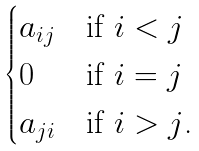<formula> <loc_0><loc_0><loc_500><loc_500>\begin{cases} a _ { i j } & \text {if $i<j$} \\ 0 & \text {if $i=j$} \\ a _ { j i } & \text {if $i>j$.} \end{cases}</formula> 